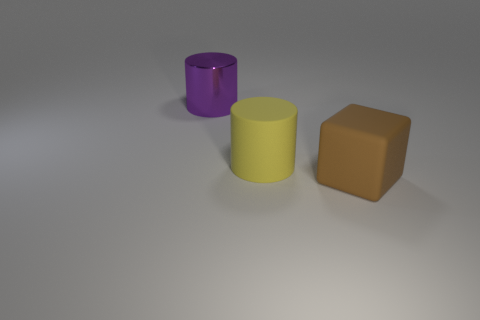What is the material of the other big object that is the same shape as the large purple metal thing?
Make the answer very short. Rubber. Is there any other thing that has the same material as the purple thing?
Give a very brief answer. No. Are there the same number of yellow things in front of the brown object and big brown rubber objects that are to the left of the big purple shiny object?
Give a very brief answer. Yes. Is the brown block made of the same material as the yellow cylinder?
Your response must be concise. Yes. What number of brown things are big shiny cylinders or rubber blocks?
Your answer should be compact. 1. How many metal objects have the same shape as the big yellow matte thing?
Your answer should be compact. 1. What material is the cube?
Your response must be concise. Rubber. Are there an equal number of shiny things in front of the big yellow matte cylinder and shiny things?
Provide a short and direct response. No. There is a brown object that is the same size as the purple object; what is its shape?
Ensure brevity in your answer.  Cube. There is a large cylinder that is to the right of the large purple shiny cylinder; is there a large thing that is left of it?
Provide a succinct answer. Yes. 